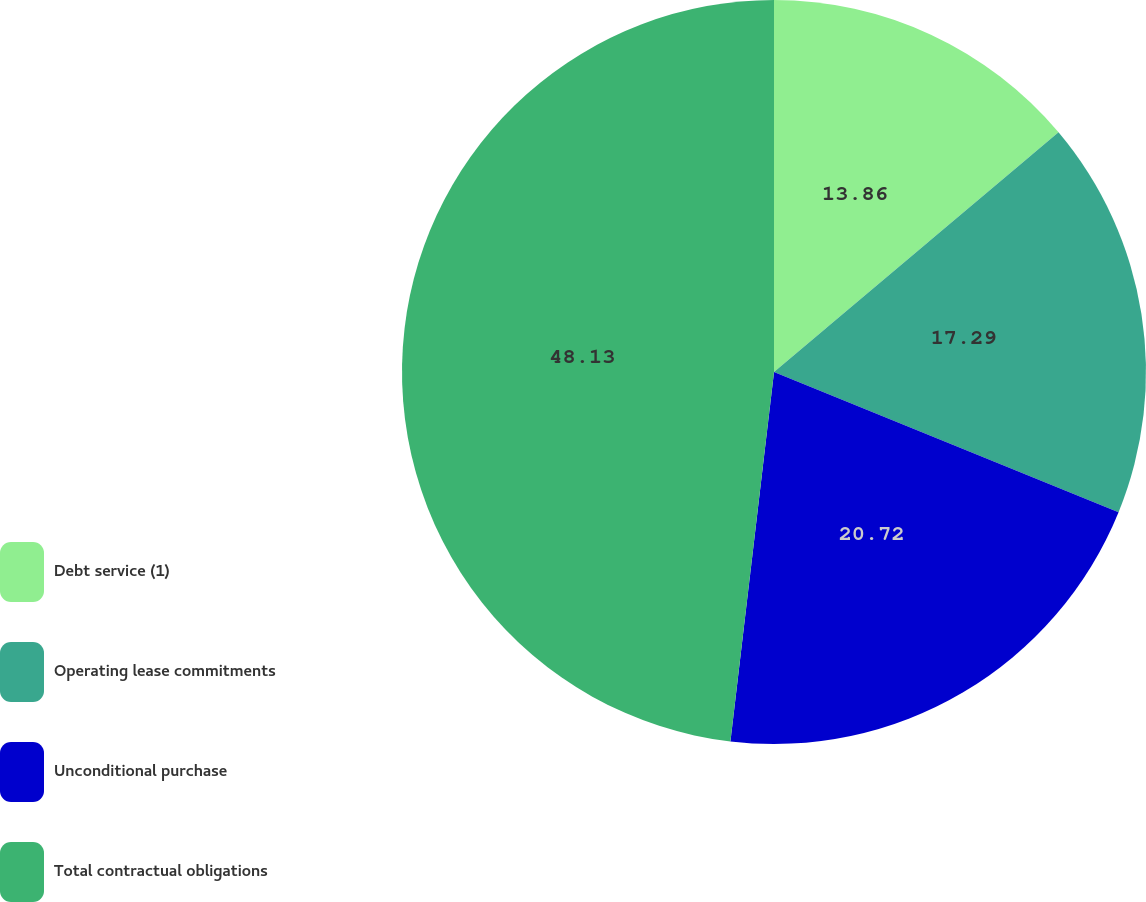Convert chart to OTSL. <chart><loc_0><loc_0><loc_500><loc_500><pie_chart><fcel>Debt service (1)<fcel>Operating lease commitments<fcel>Unconditional purchase<fcel>Total contractual obligations<nl><fcel>13.86%<fcel>17.29%<fcel>20.72%<fcel>48.13%<nl></chart> 